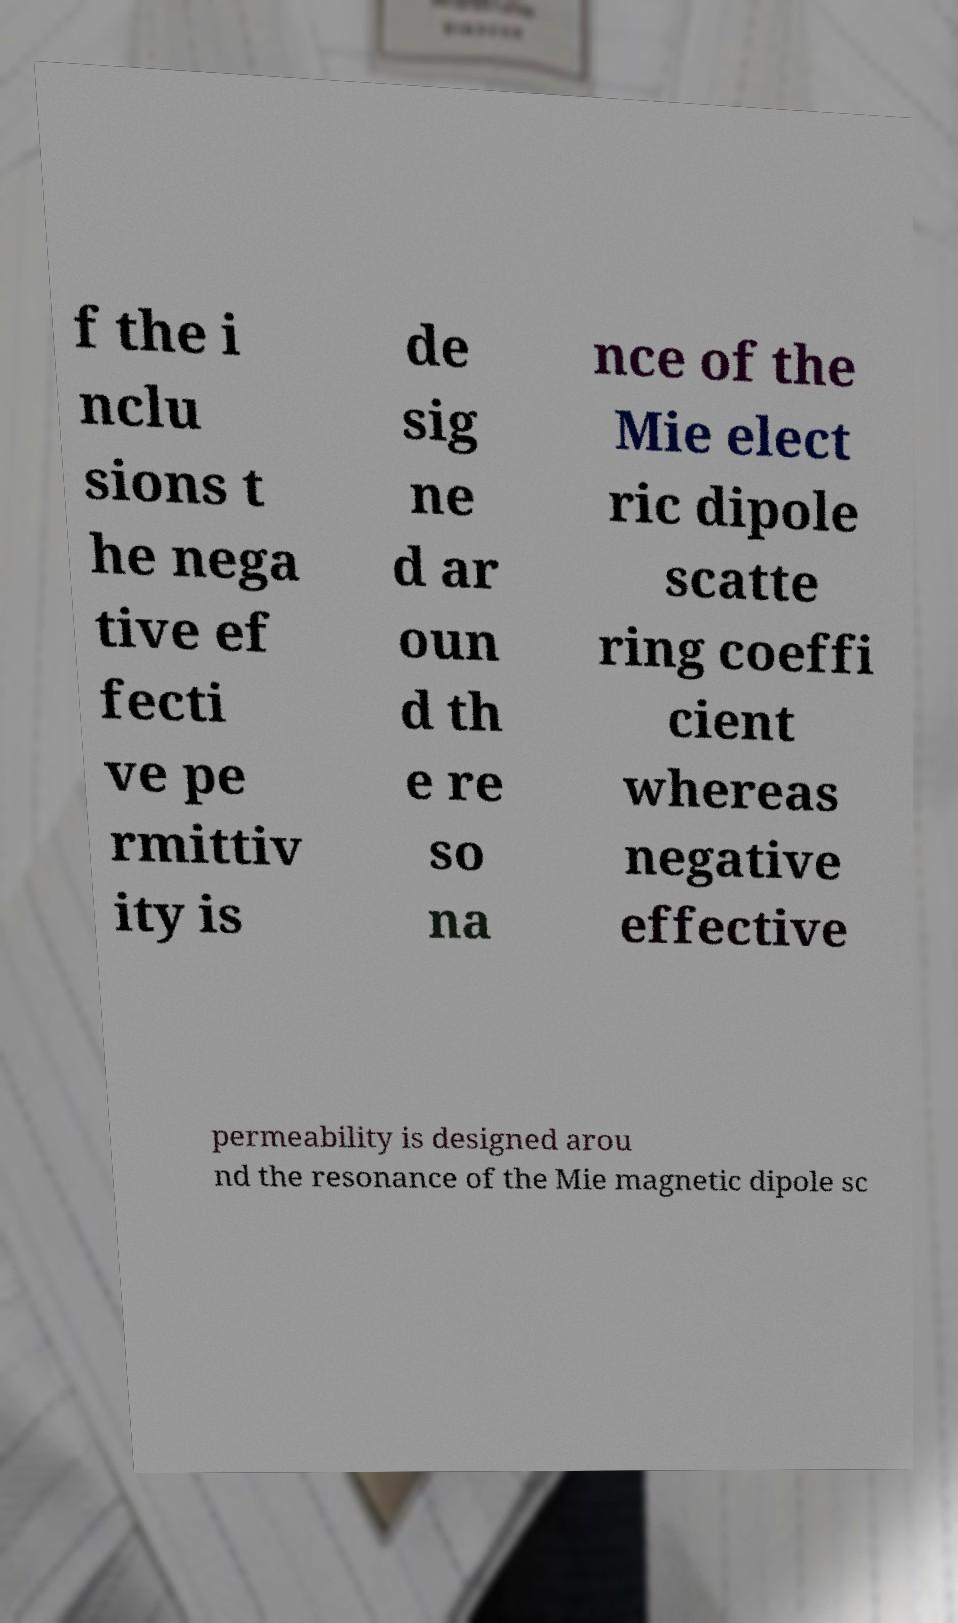For documentation purposes, I need the text within this image transcribed. Could you provide that? f the i nclu sions t he nega tive ef fecti ve pe rmittiv ity is de sig ne d ar oun d th e re so na nce of the Mie elect ric dipole scatte ring coeffi cient whereas negative effective permeability is designed arou nd the resonance of the Mie magnetic dipole sc 